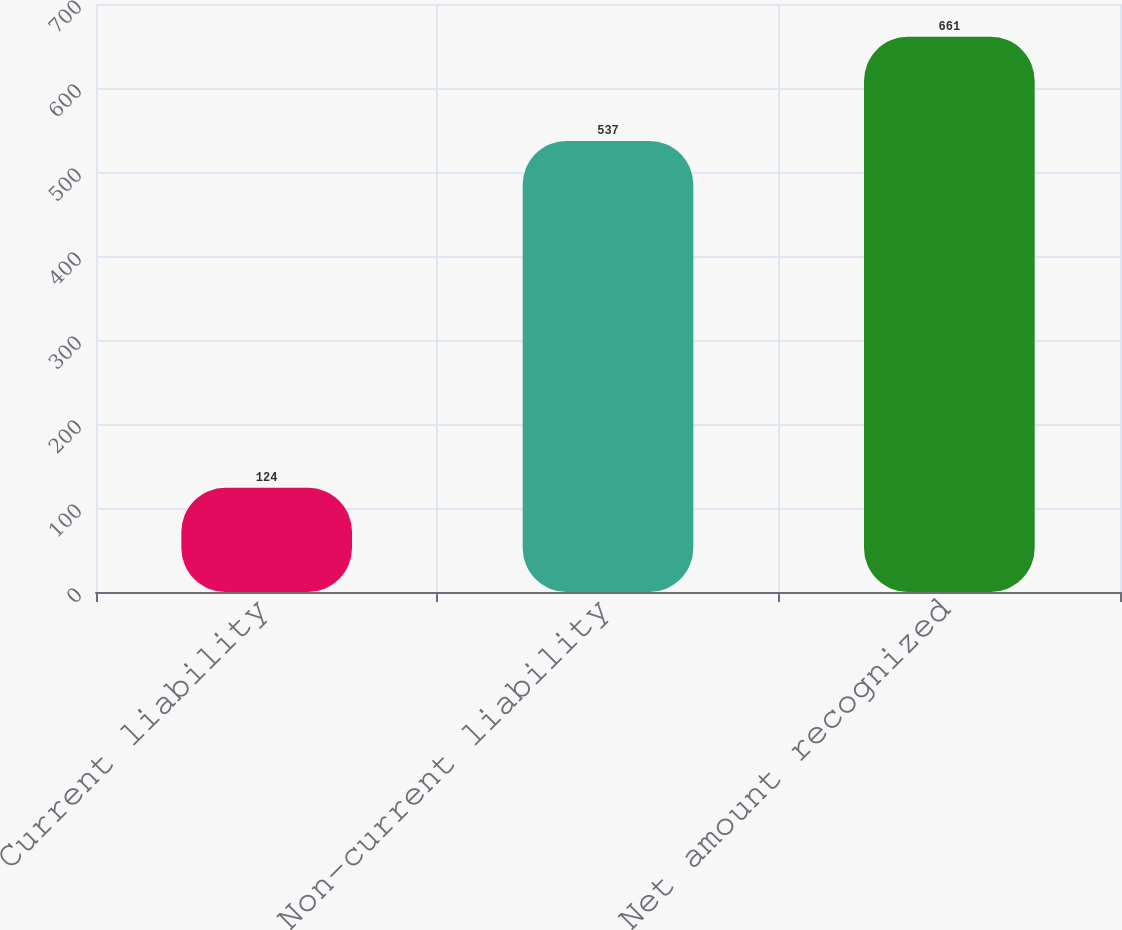<chart> <loc_0><loc_0><loc_500><loc_500><bar_chart><fcel>Current liability<fcel>Non-current liability<fcel>Net amount recognized<nl><fcel>124<fcel>537<fcel>661<nl></chart> 